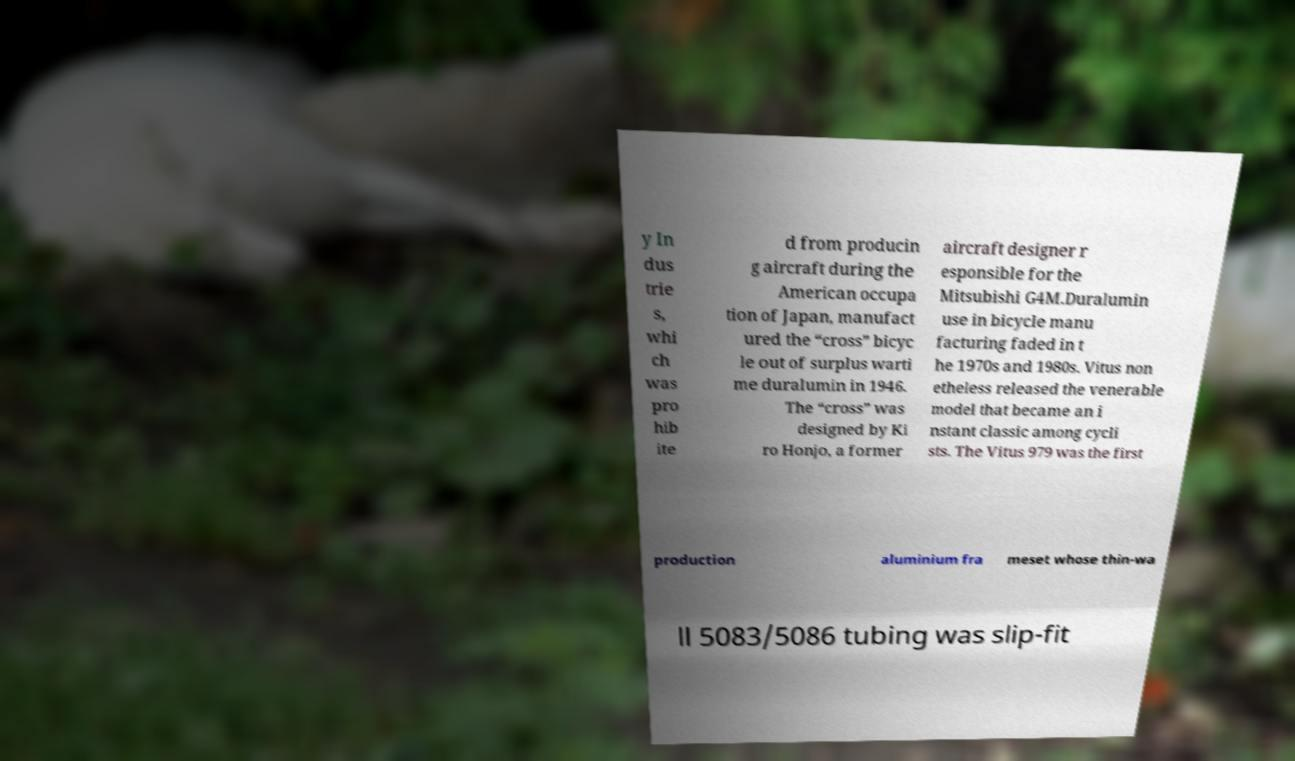I need the written content from this picture converted into text. Can you do that? y In dus trie s, whi ch was pro hib ite d from producin g aircraft during the American occupa tion of Japan, manufact ured the “cross” bicyc le out of surplus warti me duralumin in 1946. The “cross” was designed by Ki ro Honjo, a former aircraft designer r esponsible for the Mitsubishi G4M.Duralumin use in bicycle manu facturing faded in t he 1970s and 1980s. Vitus non etheless released the venerable model that became an i nstant classic among cycli sts. The Vitus 979 was the first production aluminium fra meset whose thin-wa ll 5083/5086 tubing was slip-fit 